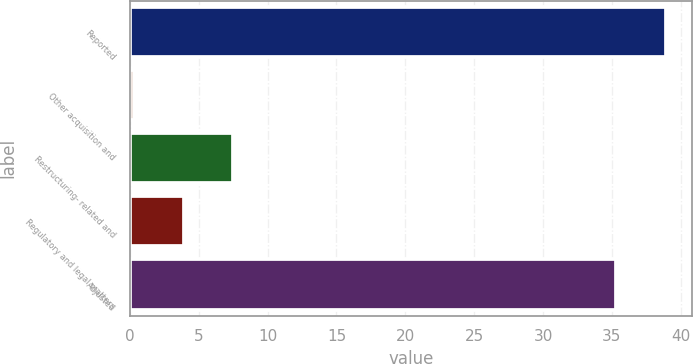Convert chart. <chart><loc_0><loc_0><loc_500><loc_500><bar_chart><fcel>Reported<fcel>Other acquisition and<fcel>Restructuring- related and<fcel>Regulatory and legal matters<fcel>Adjusted<nl><fcel>38.9<fcel>0.3<fcel>7.5<fcel>3.9<fcel>35.3<nl></chart> 